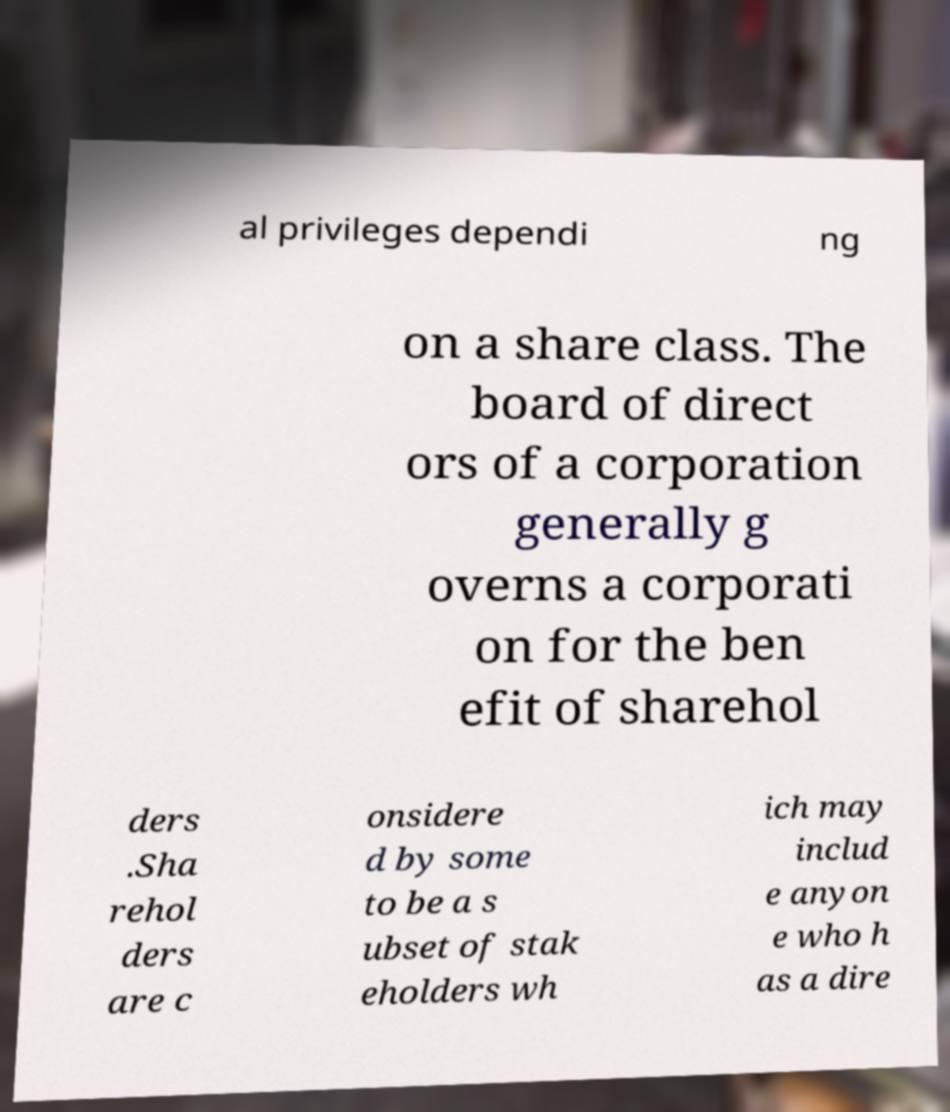For documentation purposes, I need the text within this image transcribed. Could you provide that? al privileges dependi ng on a share class. The board of direct ors of a corporation generally g overns a corporati on for the ben efit of sharehol ders .Sha rehol ders are c onsidere d by some to be a s ubset of stak eholders wh ich may includ e anyon e who h as a dire 